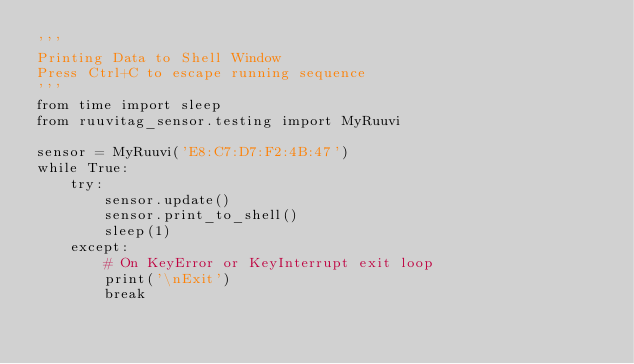<code> <loc_0><loc_0><loc_500><loc_500><_Python_>'''
Printing Data to Shell Window
Press Ctrl+C to escape running sequence
'''
from time import sleep
from ruuvitag_sensor.testing import MyRuuvi

sensor = MyRuuvi('E8:C7:D7:F2:4B:47')
while True:
    try:
        sensor.update()
        sensor.print_to_shell()
        sleep(1)
    except:
        # On KeyError or KeyInterrupt exit loop
        print('\nExit')
        break
</code> 